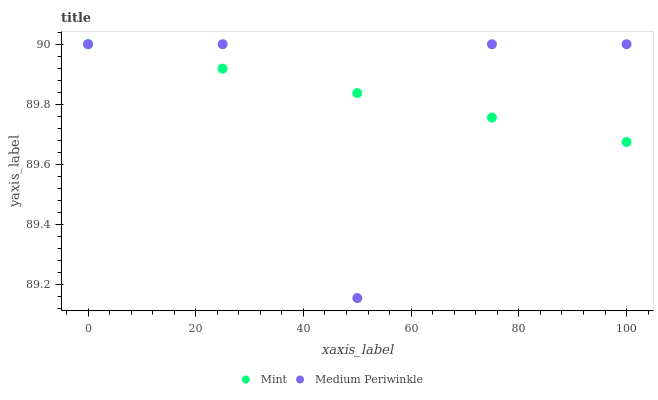Does Medium Periwinkle have the minimum area under the curve?
Answer yes or no. Yes. Does Mint have the maximum area under the curve?
Answer yes or no. Yes. Does Mint have the minimum area under the curve?
Answer yes or no. No. Is Mint the smoothest?
Answer yes or no. Yes. Is Medium Periwinkle the roughest?
Answer yes or no. Yes. Is Mint the roughest?
Answer yes or no. No. Does Medium Periwinkle have the lowest value?
Answer yes or no. Yes. Does Mint have the lowest value?
Answer yes or no. No. Does Mint have the highest value?
Answer yes or no. Yes. Does Mint intersect Medium Periwinkle?
Answer yes or no. Yes. Is Mint less than Medium Periwinkle?
Answer yes or no. No. Is Mint greater than Medium Periwinkle?
Answer yes or no. No. 